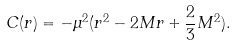<formula> <loc_0><loc_0><loc_500><loc_500>C ( r ) = - \mu ^ { 2 } ( r ^ { 2 } - 2 M r + \frac { 2 } { 3 } M ^ { 2 } ) .</formula> 